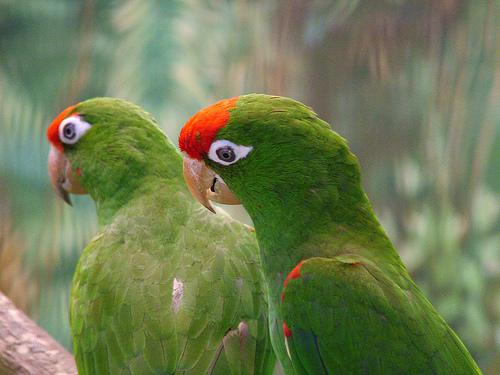Question: what color are the birds?
Choices:
A. Blue.
B. Green white and orange.
C. White.
D. Grey and brown.
Answer with the letter. Answer: B Question: what animal is this?
Choices:
A. Bird.
B. Cow.
C. Dog.
D. Cat.
Answer with the letter. Answer: A Question: how many birds are there?
Choices:
A. Three.
B. Two.
C. Four.
D. Five.
Answer with the letter. Answer: B Question: how many eyes can be seen?
Choices:
A. One.
B. Three.
C. Two.
D. Four.
Answer with the letter. Answer: C Question: how are the birds positioned?
Choices:
A. Every which way.
B. Flying left.
C. Flying right.
D. Facing the same way.
Answer with the letter. Answer: D 